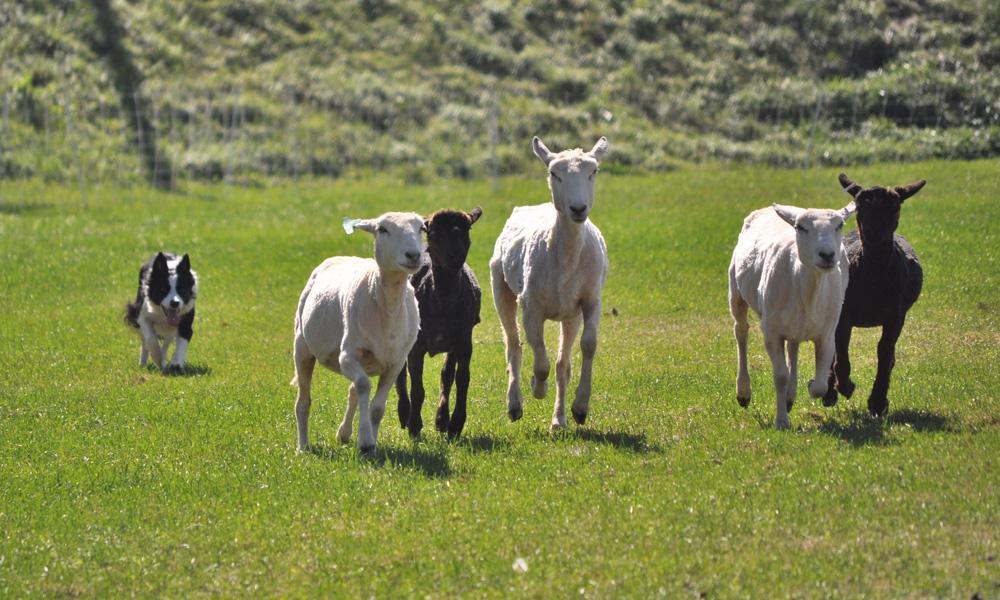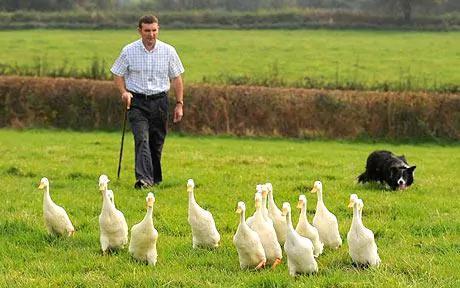The first image is the image on the left, the second image is the image on the right. For the images displayed, is the sentence "One image shows a dog herding water fowl." factually correct? Answer yes or no. Yes. 